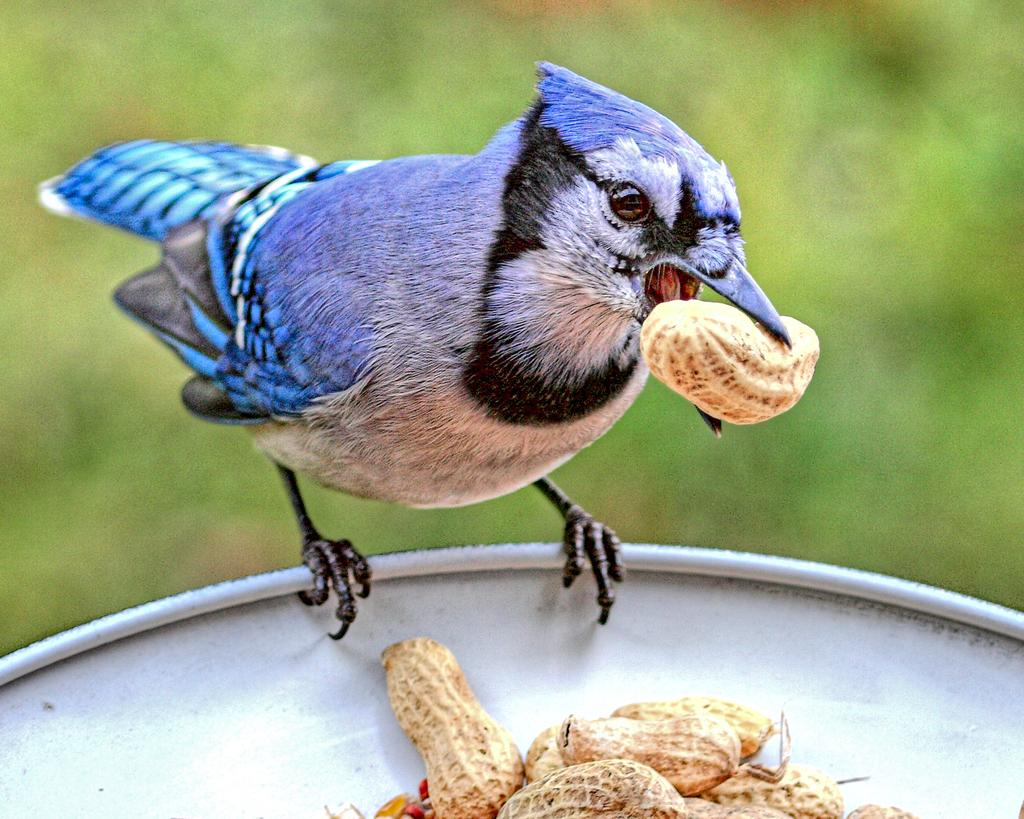What type of animal is in the image? There is a bird in the image. What is the bird holding in its mouth? The bird is holding a groundnut in its mouth. What can be seen in the image besides the bird? There is a container in the image. What is the color of the background in the image? The background of the image is greenish. What type of government is depicted in the image? There is no depiction of a government in the image; it features a bird holding a groundnut and a container in a greenish background. How far away is the cable from the bird in the image? There is no cable present in the image. 